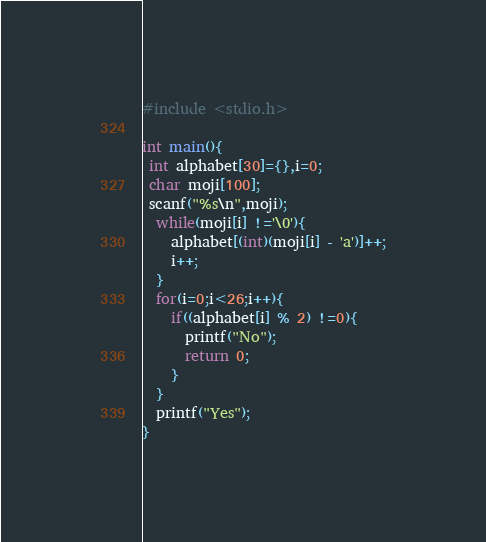<code> <loc_0><loc_0><loc_500><loc_500><_C_>#include <stdio.h>

int main(){
 int alphabet[30]={},i=0;
 char moji[100];
 scanf("%s\n",moji);
  while(moji[i] !='\0'){
    alphabet[(int)(moji[i] - 'a')]++;
    i++;
  }
  for(i=0;i<26;i++){
    if((alphabet[i] % 2) !=0){
      printf("No");
      return 0;
    }
  }
  printf("Yes");
}</code> 